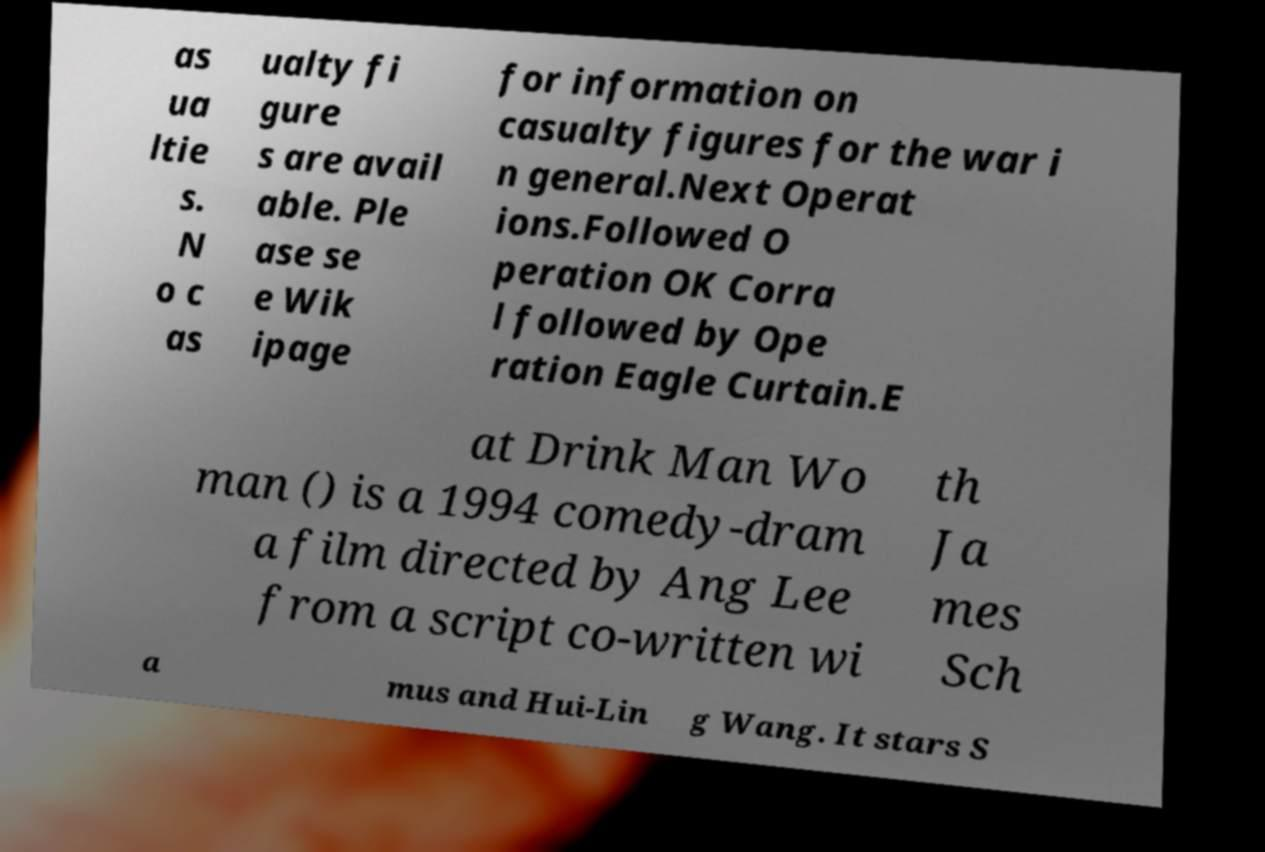For documentation purposes, I need the text within this image transcribed. Could you provide that? as ua ltie s. N o c as ualty fi gure s are avail able. Ple ase se e Wik ipage for information on casualty figures for the war i n general.Next Operat ions.Followed O peration OK Corra l followed by Ope ration Eagle Curtain.E at Drink Man Wo man () is a 1994 comedy-dram a film directed by Ang Lee from a script co-written wi th Ja mes Sch a mus and Hui-Lin g Wang. It stars S 